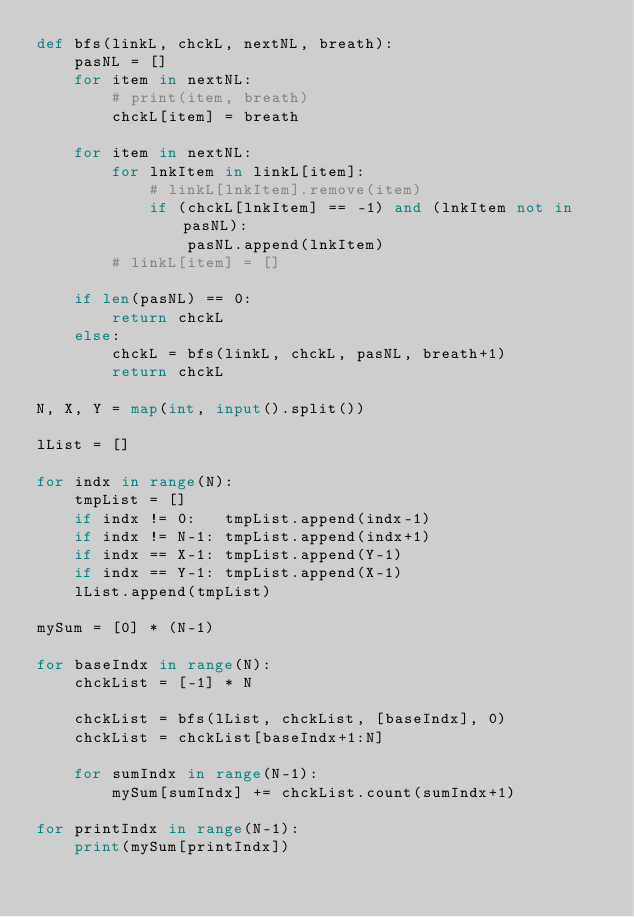<code> <loc_0><loc_0><loc_500><loc_500><_Python_>def bfs(linkL, chckL, nextNL, breath):
    pasNL = []
    for item in nextNL:
        # print(item, breath)
        chckL[item] = breath

    for item in nextNL:
        for lnkItem in linkL[item]:
            # linkL[lnkItem].remove(item)
            if (chckL[lnkItem] == -1) and (lnkItem not in pasNL):
                pasNL.append(lnkItem)
        # linkL[item] = []
    
    if len(pasNL) == 0:
        return chckL
    else:
        chckL = bfs(linkL, chckL, pasNL, breath+1)
        return chckL

N, X, Y = map(int, input().split())

lList = []

for indx in range(N):
    tmpList = []
    if indx != 0:   tmpList.append(indx-1)
    if indx != N-1: tmpList.append(indx+1)
    if indx == X-1: tmpList.append(Y-1)
    if indx == Y-1: tmpList.append(X-1)
    lList.append(tmpList)

mySum = [0] * (N-1)

for baseIndx in range(N):
    chckList = [-1] * N

    chckList = bfs(lList, chckList, [baseIndx], 0)
    chckList = chckList[baseIndx+1:N]

    for sumIndx in range(N-1):
        mySum[sumIndx] += chckList.count(sumIndx+1)

for printIndx in range(N-1):
    print(mySum[printIndx])

</code> 